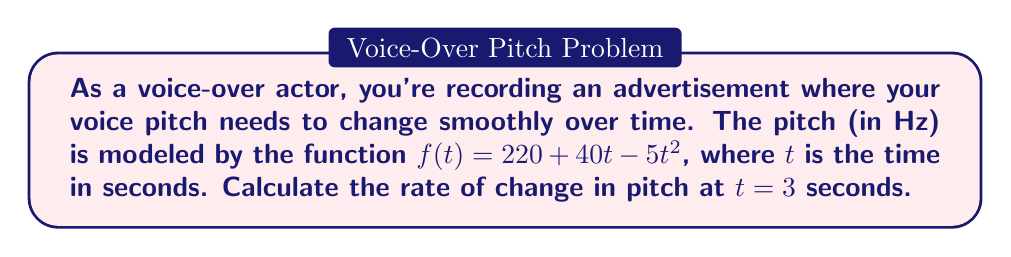Give your solution to this math problem. To find the rate of change in pitch at a specific time, we need to calculate the derivative of the given function and evaluate it at the given time.

1. Given function: $f(t) = 220 + 40t - 5t^2$

2. Calculate the derivative:
   $f'(t) = \frac{d}{dt}(220 + 40t - 5t^2)$
   $f'(t) = 0 + 40 - 10t$
   $f'(t) = 40 - 10t$

3. Evaluate the derivative at $t = 3$ seconds:
   $f'(3) = 40 - 10(3)$
   $f'(3) = 40 - 30$
   $f'(3) = 10$

The rate of change at $t = 3$ seconds is 10 Hz/s.
Answer: 10 Hz/s 